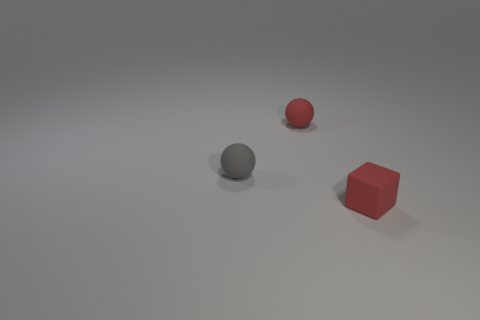Do the matte cube and the sphere that is behind the gray sphere have the same color?
Offer a terse response. Yes. How many big objects are cubes or brown metallic objects?
Provide a succinct answer. 0. Is the tiny ball that is in front of the red sphere made of the same material as the small red cube?
Provide a short and direct response. Yes. There is a tiny red object behind the red matte thing that is in front of the small thing behind the tiny gray rubber ball; what is its material?
Ensure brevity in your answer.  Rubber. How many rubber objects are gray spheres or tiny brown balls?
Offer a very short reply. 1. Are any small cyan matte balls visible?
Keep it short and to the point. No. What color is the matte sphere that is on the left side of the tiny red thing to the left of the small red rubber cube?
Your response must be concise. Gray. How many other objects are there of the same color as the matte block?
Offer a terse response. 1. How many objects are either gray objects or rubber objects that are left of the tiny red ball?
Your response must be concise. 1. What color is the matte sphere in front of the small red rubber sphere?
Give a very brief answer. Gray. 